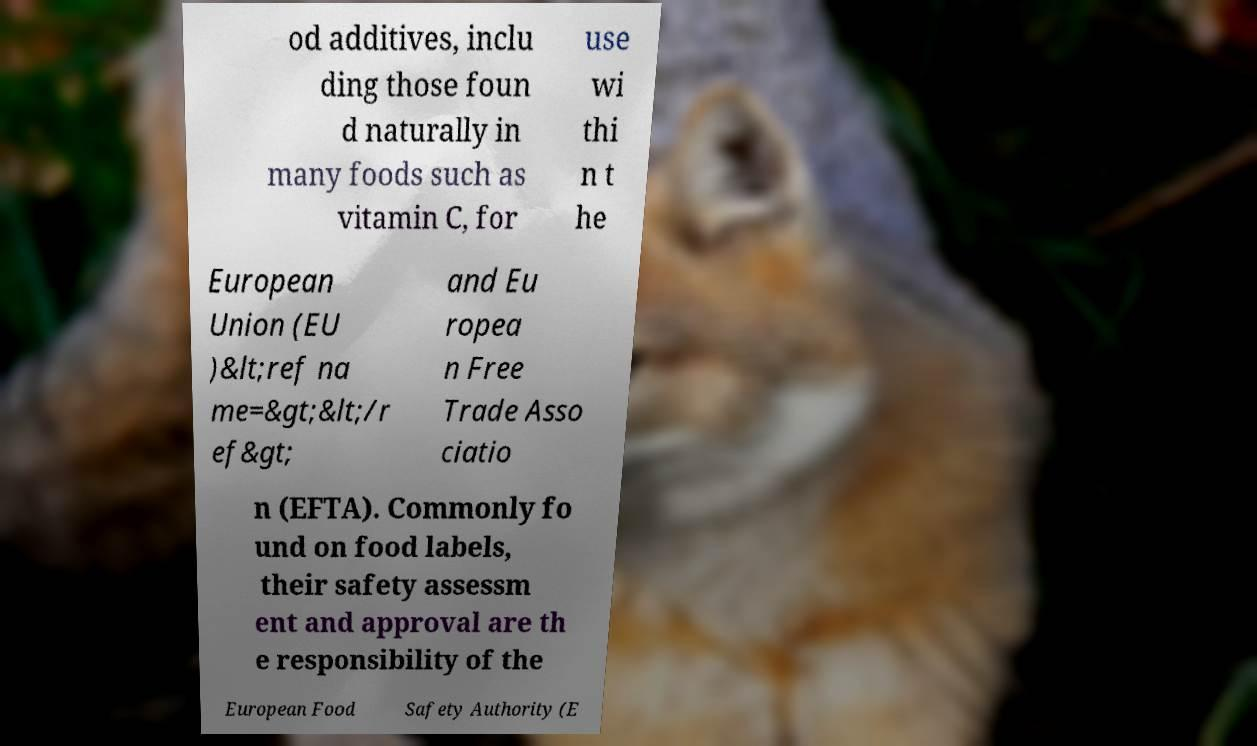I need the written content from this picture converted into text. Can you do that? od additives, inclu ding those foun d naturally in many foods such as vitamin C, for use wi thi n t he European Union (EU )&lt;ref na me=&gt;&lt;/r ef&gt; and Eu ropea n Free Trade Asso ciatio n (EFTA). Commonly fo und on food labels, their safety assessm ent and approval are th e responsibility of the European Food Safety Authority (E 